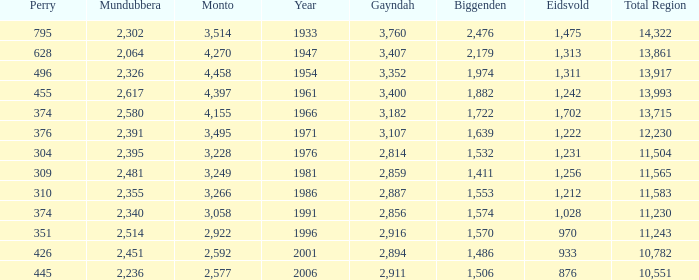What is the Total Region number of hte one that has Eidsvold at 970 and Biggenden larger than 1,570? 0.0. 